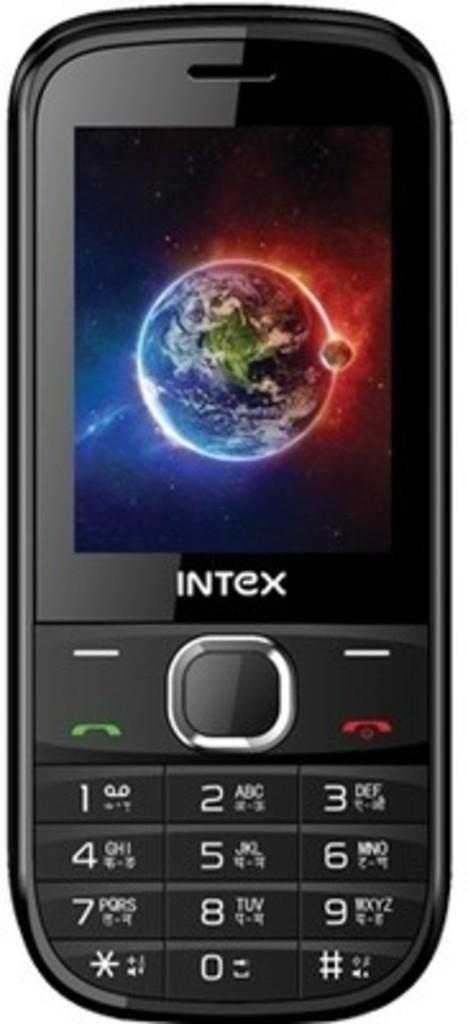<image>
Describe the image concisely. A black cell phone says Intex and shows an Earth on the screen. 